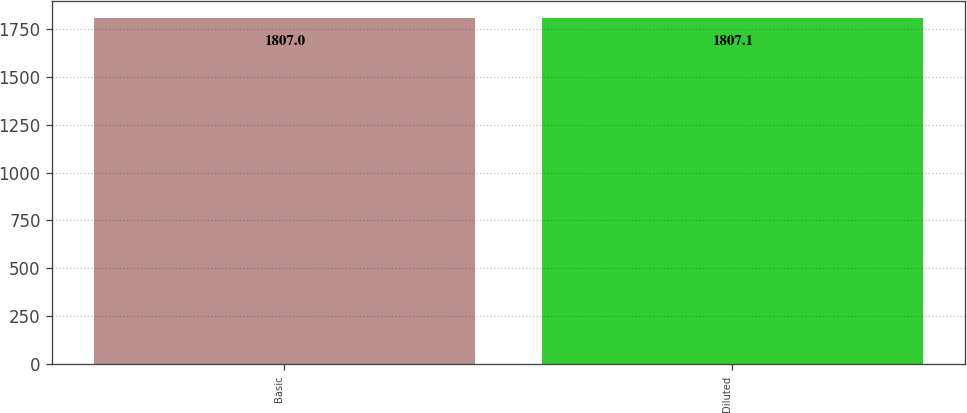Convert chart to OTSL. <chart><loc_0><loc_0><loc_500><loc_500><bar_chart><fcel>Basic<fcel>Diluted<nl><fcel>1807<fcel>1807.1<nl></chart> 